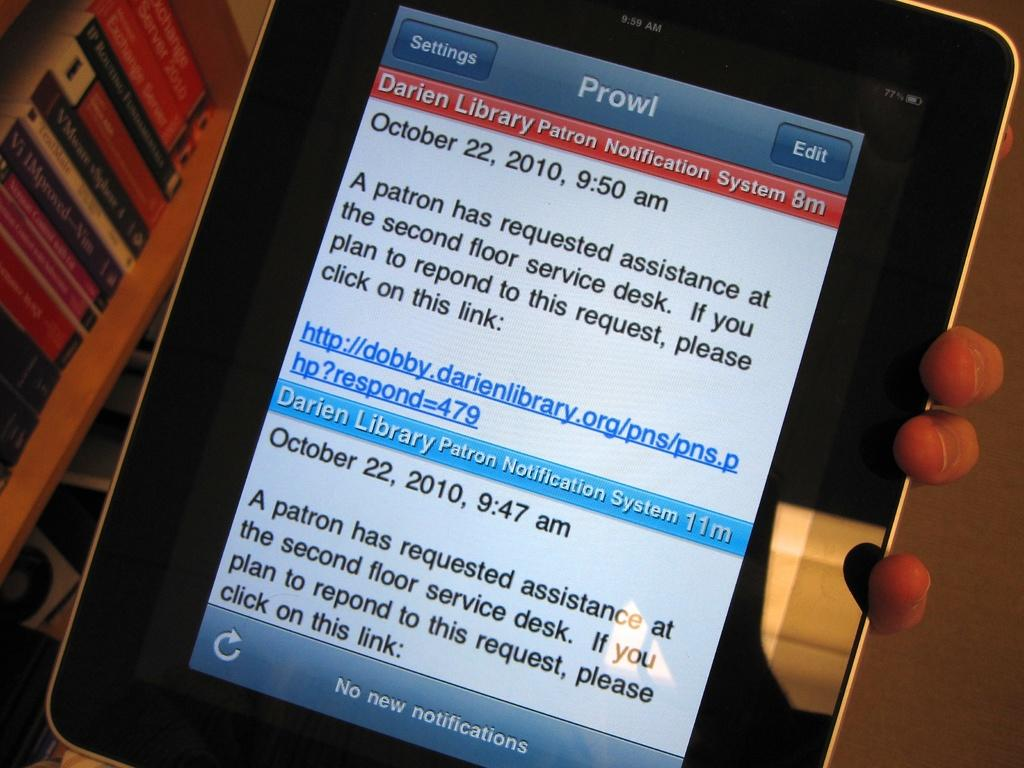<image>
Summarize the visual content of the image. A tablet has a message from the Darien Library. 